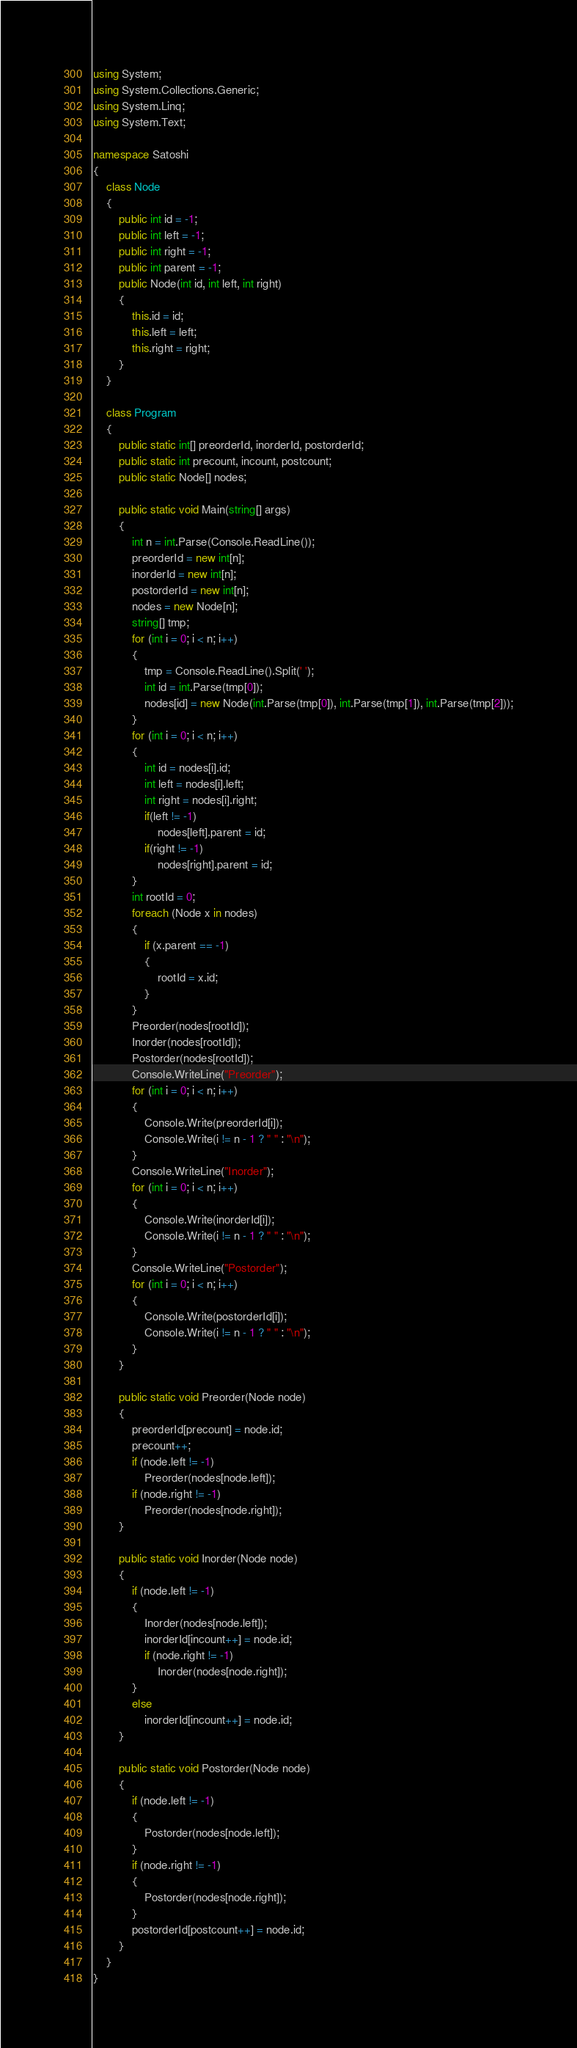Convert code to text. <code><loc_0><loc_0><loc_500><loc_500><_C#_>using System;
using System.Collections.Generic;
using System.Linq;
using System.Text;

namespace Satoshi
{
	class Node
	{
		public int id = -1;
		public int left = -1;
		public int right = -1;
		public int parent = -1;
		public Node(int id, int left, int right)
		{
			this.id = id;
			this.left = left;
			this.right = right;
		}
	}

	class Program
	{
		public static int[] preorderId, inorderId, postorderId;
		public static int precount, incount, postcount;
		public static Node[] nodes;

		public static void Main(string[] args)
		{
			int n = int.Parse(Console.ReadLine());
			preorderId = new int[n];
			inorderId = new int[n];
			postorderId = new int[n];
			nodes = new Node[n];
			string[] tmp;
			for (int i = 0; i < n; i++)
			{
				tmp = Console.ReadLine().Split(' ');
				int id = int.Parse(tmp[0]);
				nodes[id] = new Node(int.Parse(tmp[0]), int.Parse(tmp[1]), int.Parse(tmp[2]));
			}
			for (int i = 0; i < n; i++)
			{
				int id = nodes[i].id;
				int left = nodes[i].left;
				int right = nodes[i].right;
				if(left != -1)
					nodes[left].parent = id;
				if(right != -1)
					nodes[right].parent = id;
			}
			int rootId = 0;
			foreach (Node x in nodes)
			{
				if (x.parent == -1)
				{
					rootId = x.id;
				}
			}
			Preorder(nodes[rootId]);
			Inorder(nodes[rootId]);
			Postorder(nodes[rootId]);
			Console.WriteLine("Preorder");
			for (int i = 0; i < n; i++)
			{
				Console.Write(preorderId[i]);
				Console.Write(i != n - 1 ? " " : "\n");
			}
			Console.WriteLine("Inorder");
			for (int i = 0; i < n; i++)
			{
				Console.Write(inorderId[i]);
				Console.Write(i != n - 1 ? " " : "\n");
			}
			Console.WriteLine("Postorder");
			for (int i = 0; i < n; i++)
			{
				Console.Write(postorderId[i]);
				Console.Write(i != n - 1 ? " " : "\n");
			}
		}

		public static void Preorder(Node node)
		{
			preorderId[precount] = node.id;
			precount++;
			if (node.left != -1)
				Preorder(nodes[node.left]);
			if (node.right != -1)
				Preorder(nodes[node.right]);
		}

		public static void Inorder(Node node)
		{
			if (node.left != -1)
			{
				Inorder(nodes[node.left]);
				inorderId[incount++] = node.id;
				if (node.right != -1)
					Inorder(nodes[node.right]);
			}
			else
				inorderId[incount++] = node.id;
		}

		public static void Postorder(Node node)
		{
			if (node.left != -1)
			{
				Postorder(nodes[node.left]);
			}
			if (node.right != -1)
			{
				Postorder(nodes[node.right]);
			}
			postorderId[postcount++] = node.id;
		}
	}
}</code> 